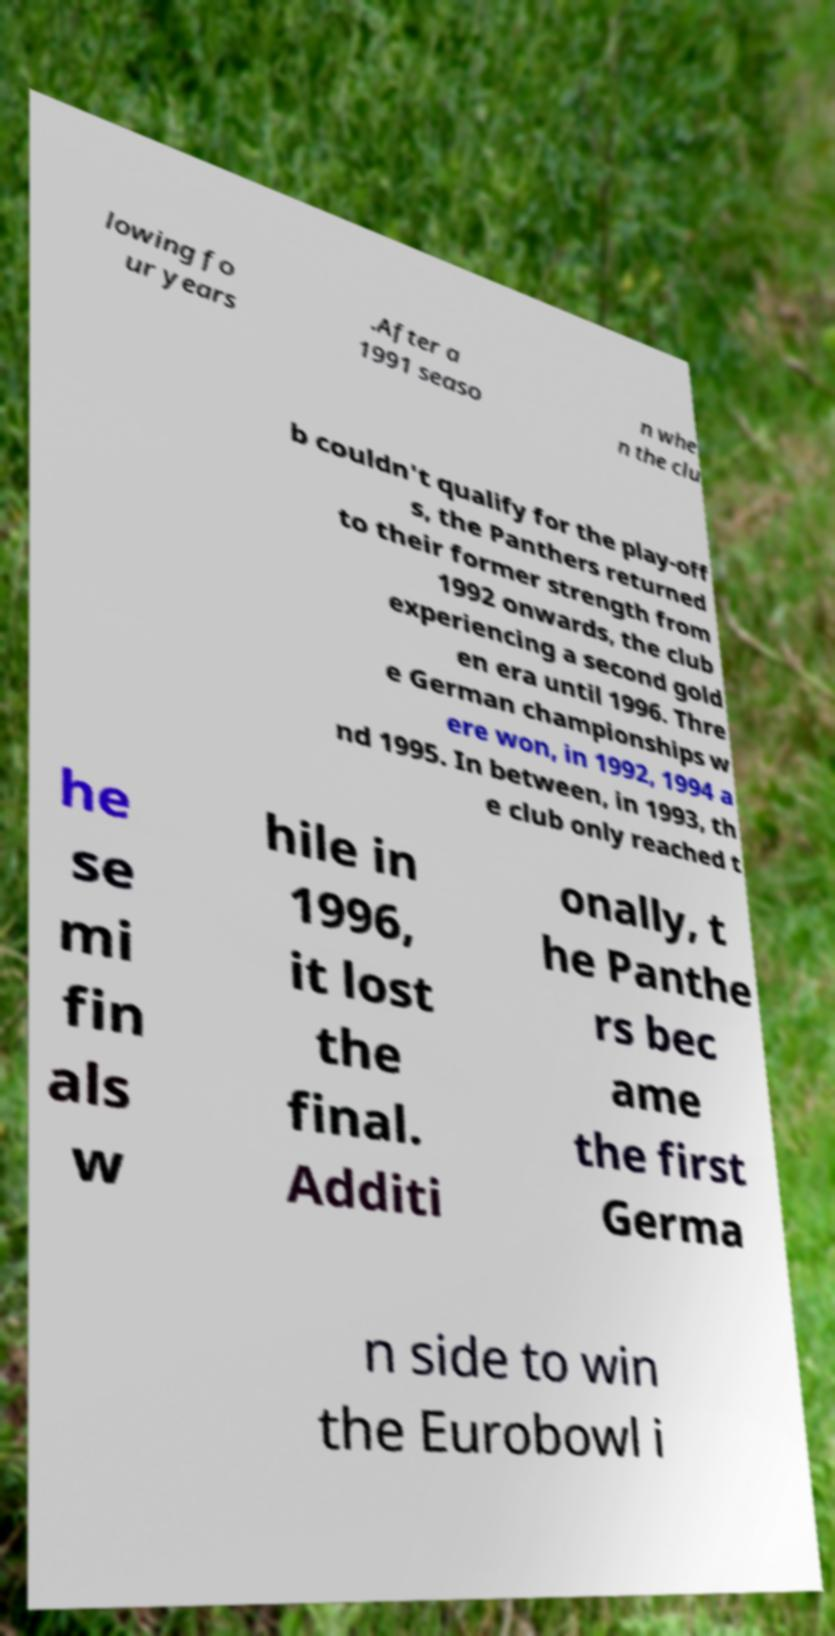There's text embedded in this image that I need extracted. Can you transcribe it verbatim? lowing fo ur years .After a 1991 seaso n whe n the clu b couldn't qualify for the play-off s, the Panthers returned to their former strength from 1992 onwards, the club experiencing a second gold en era until 1996. Thre e German championships w ere won, in 1992, 1994 a nd 1995. In between, in 1993, th e club only reached t he se mi fin als w hile in 1996, it lost the final. Additi onally, t he Panthe rs bec ame the first Germa n side to win the Eurobowl i 